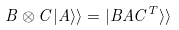<formula> <loc_0><loc_0><loc_500><loc_500>B \otimes C | A \rangle \rangle = | B A C ^ { T } \rangle \rangle</formula> 